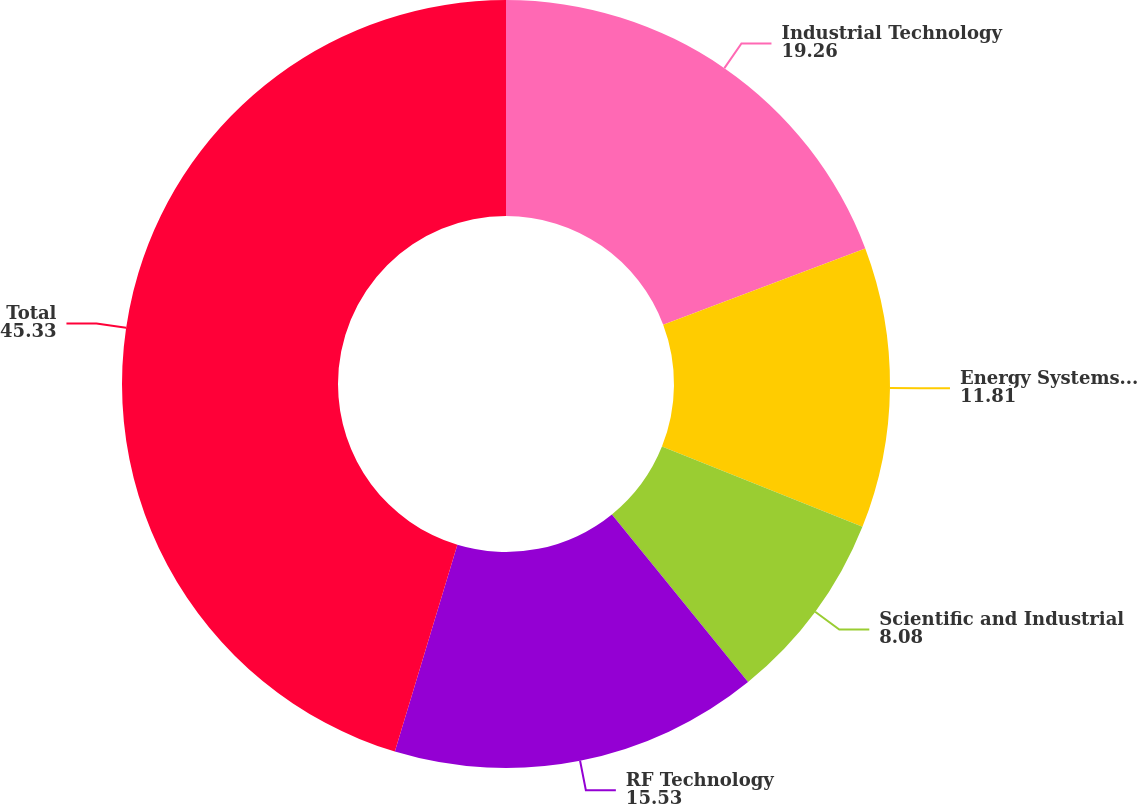<chart> <loc_0><loc_0><loc_500><loc_500><pie_chart><fcel>Industrial Technology<fcel>Energy Systems and Controls<fcel>Scientific and Industrial<fcel>RF Technology<fcel>Total<nl><fcel>19.26%<fcel>11.81%<fcel>8.08%<fcel>15.53%<fcel>45.33%<nl></chart> 